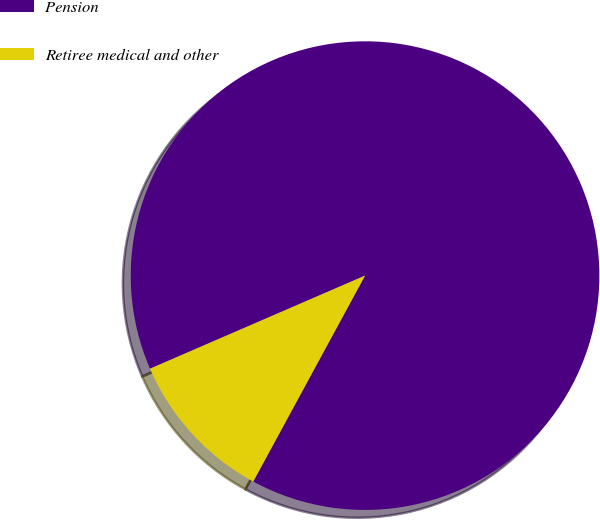Convert chart to OTSL. <chart><loc_0><loc_0><loc_500><loc_500><pie_chart><fcel>Pension<fcel>Retiree medical and other<nl><fcel>89.42%<fcel>10.58%<nl></chart> 